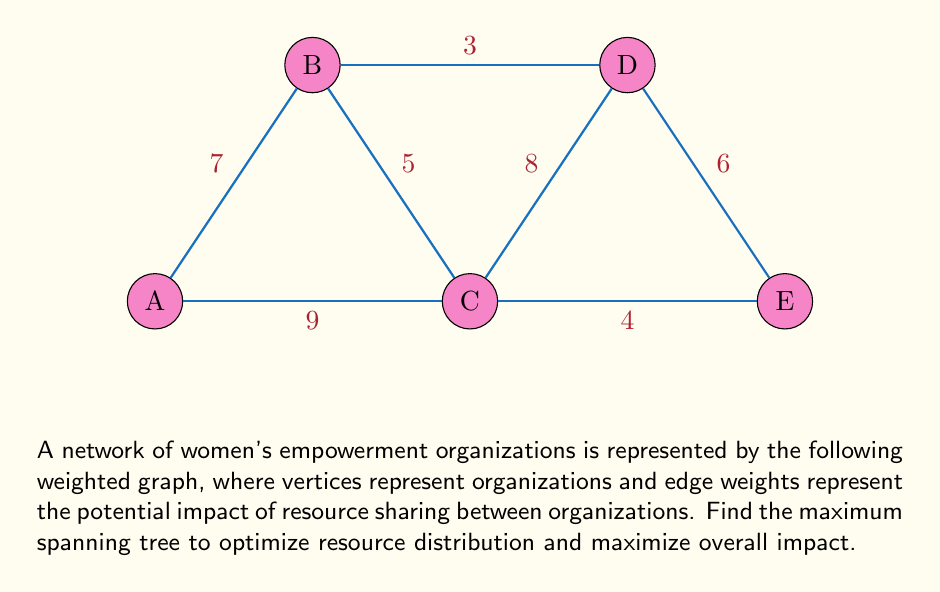Solve this math problem. To find the maximum spanning tree, we'll use Kruskal's algorithm in reverse order (selecting the highest weight edges first):

1. Sort edges by weight in descending order:
   AC (9), CD (8), AB (7), DE (6), BC (5), CE (4), BD (3)

2. Start with an empty set of edges and add edges that don't create cycles:
   - Add AC (9)
   - Add CD (8)
   - Add AB (7)
   - Add DE (6)

3. The maximum spanning tree is now complete with 4 edges connecting all 5 vertices.

4. Calculate the total weight:
   $W_{total} = 9 + 8 + 7 + 6 = 30$

The maximum spanning tree consists of edges AC, CD, AB, and DE, with a total weight of 30.

This solution ensures optimal resource distribution by maximizing the potential impact of connections between women's empowerment organizations.
Answer: Edges: AC, CD, AB, DE; Total weight: 30 